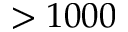<formula> <loc_0><loc_0><loc_500><loc_500>> 1 0 0 0</formula> 